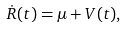<formula> <loc_0><loc_0><loc_500><loc_500>\dot { R } ( t ) = \mu + V ( t ) ,</formula> 